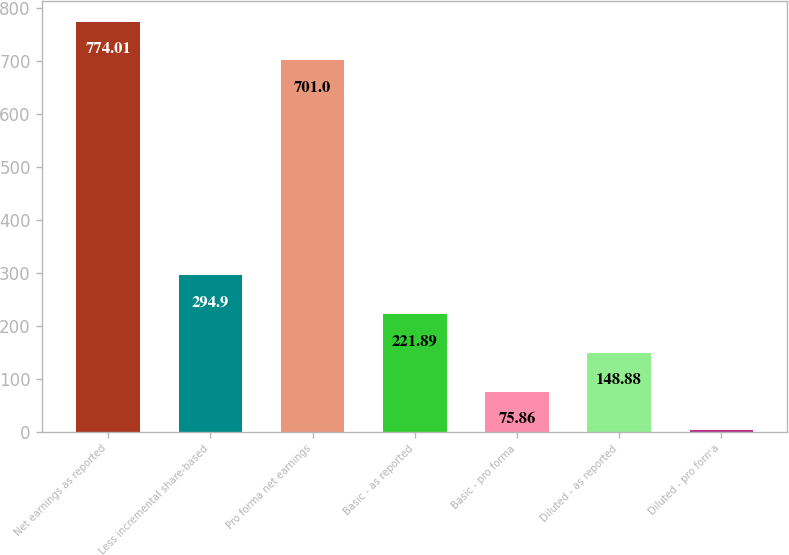<chart> <loc_0><loc_0><loc_500><loc_500><bar_chart><fcel>Net earnings as reported<fcel>Less incremental share-based<fcel>Pro forma net earnings<fcel>Basic - as reported<fcel>Basic - pro forma<fcel>Diluted - as reported<fcel>Diluted - pro forma<nl><fcel>774.01<fcel>294.9<fcel>701<fcel>221.89<fcel>75.86<fcel>148.88<fcel>2.85<nl></chart> 